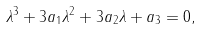<formula> <loc_0><loc_0><loc_500><loc_500>\lambda ^ { 3 } + 3 a _ { 1 } \lambda ^ { 2 } + 3 a _ { 2 } \lambda + a _ { 3 } = 0 ,</formula> 